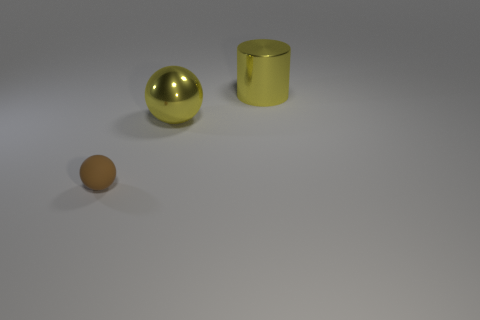There is a big metal object in front of the yellow metallic cylinder; what shape is it?
Offer a very short reply. Sphere. What shape is the object that is on the right side of the tiny rubber thing and left of the yellow metallic cylinder?
Offer a very short reply. Sphere. How many yellow things are small rubber things or cylinders?
Provide a short and direct response. 1. There is a large metallic thing left of the big cylinder; does it have the same color as the metallic cylinder?
Keep it short and to the point. Yes. How big is the thing behind the ball that is behind the tiny brown rubber object?
Your answer should be very brief. Large. There is a ball that is the same size as the cylinder; what material is it?
Keep it short and to the point. Metal. How many other things are the same size as the metal sphere?
Your response must be concise. 1. How many blocks are either tiny brown matte objects or small blue shiny things?
Your answer should be very brief. 0. Is there anything else that is the same material as the tiny brown sphere?
Ensure brevity in your answer.  No. What is the material of the small brown sphere that is in front of the large metallic object that is behind the ball that is on the right side of the small brown sphere?
Provide a short and direct response. Rubber. 